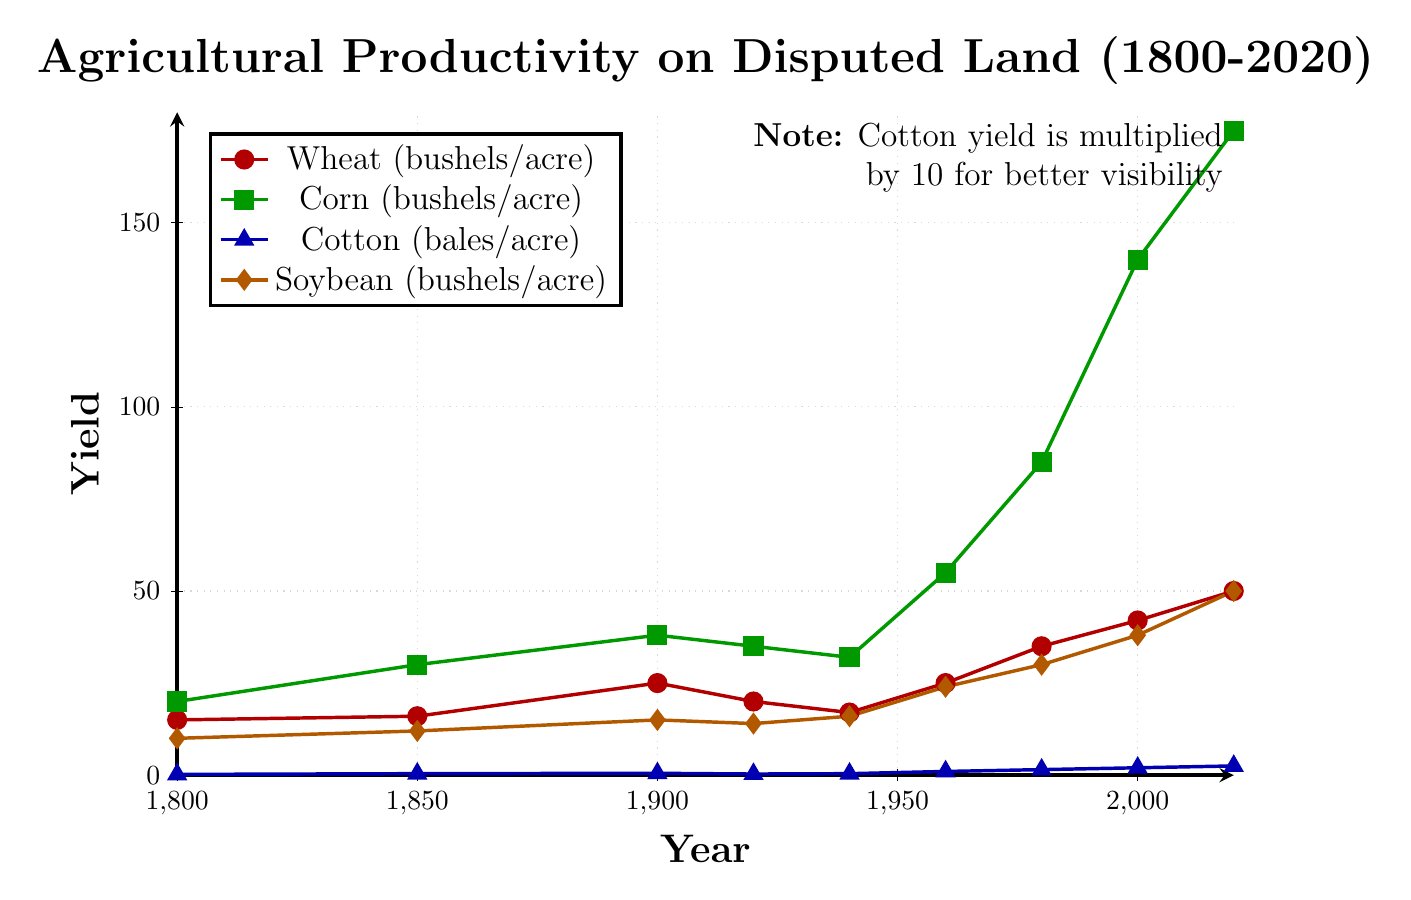What trend does the wheat yield show from 1900 to 2020? From 1900 to 2020, the wheat yield generally shows an increasing trend. Specifically, it increases from 25 bushels/acre in 1900 to 50 bushels/acre in 2020, with a notable decrease around 1920 and 1940 but subsequently rises continuously.
Answer: Increasing Which crop shows the most significant increase in yield from 1800 to 2020? To determine which crop shows the most significant increase, compare the yield values from 1800 and 2020 for each crop. Wheat increases from 15 to 50 bushels/acre, corn from 20 to 175 bushels/acre, cotton from 0.2 to 2.5 bales/acre, and soybean from 10 to 50 bushels/acre. The most significant increase is seen with corn, which increases by 155 bushels/acre.
Answer: Corn In which year did soybean yield surpass 20 bushels/acre? By examining the data points for soybean, observe that the yield surpasses 20 bushels/acre in 1960 when it reaches 24 bushels/acre. Prior to that, it was below 20 bushels/acre.
Answer: 1960 How does the cotton yield in 2000 compare to that in 1920? Look at the values for cotton yield in the years 2000 and 1920. In 2000, the yield is 2.0 bales/acre, whereas, in 1920, it is 0.3 bales/acre. This means the yield in 2000 is significantly higher.
Answer: Higher Between which years does the corn yield show the most rapid increase? To find the period of the most rapid increase, calculate the difference in yield between successive intervals for corn. The largest difference is between 2000 and 2020, where the yield increases from 140 to 175 bushels/acre, a difference of 35 bushels/acre.
Answer: 2000-2020 What is the average wheat yield for the entire period shown? Sum the wheat yields and divide by the number of data points. The sum of the yields is 15 + 16 + 25 + 20 + 17 + 25 + 35 + 42 + 50 = 245. There are 9 data points, hence the average yield is 245/9 ≈ 27.22 bushels/acre.
Answer: 27.22 bushels/acre Which crop had the lowest yield in 1800, and what was it? Observing the values for all crops in 1800, cotton had the lowest yield with 0.2 bales/acre.
Answer: Cotton, 0.2 bales/acre By how much did the soybean yield increase from 1940 to 1980? Calculate the difference between the soybean yields in 1980 and 1940: 30 - 16 = 14 bushels/acre.
Answer: 14 bushels/acre Which crop shows almost a linear trend in its yield over the years? By visually inspecting the graph, the corn yield shows an almost linear increasing trend from 1800 to 2020 without any significant fluctuations.
Answer: Corn 